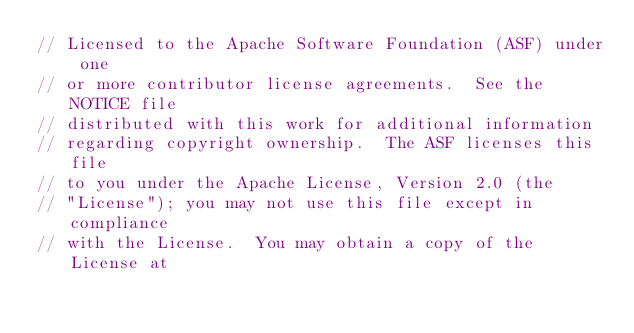<code> <loc_0><loc_0><loc_500><loc_500><_C_>// Licensed to the Apache Software Foundation (ASF) under one
// or more contributor license agreements.  See the NOTICE file
// distributed with this work for additional information
// regarding copyright ownership.  The ASF licenses this file
// to you under the Apache License, Version 2.0 (the
// "License"); you may not use this file except in compliance
// with the License.  You may obtain a copy of the License at</code> 